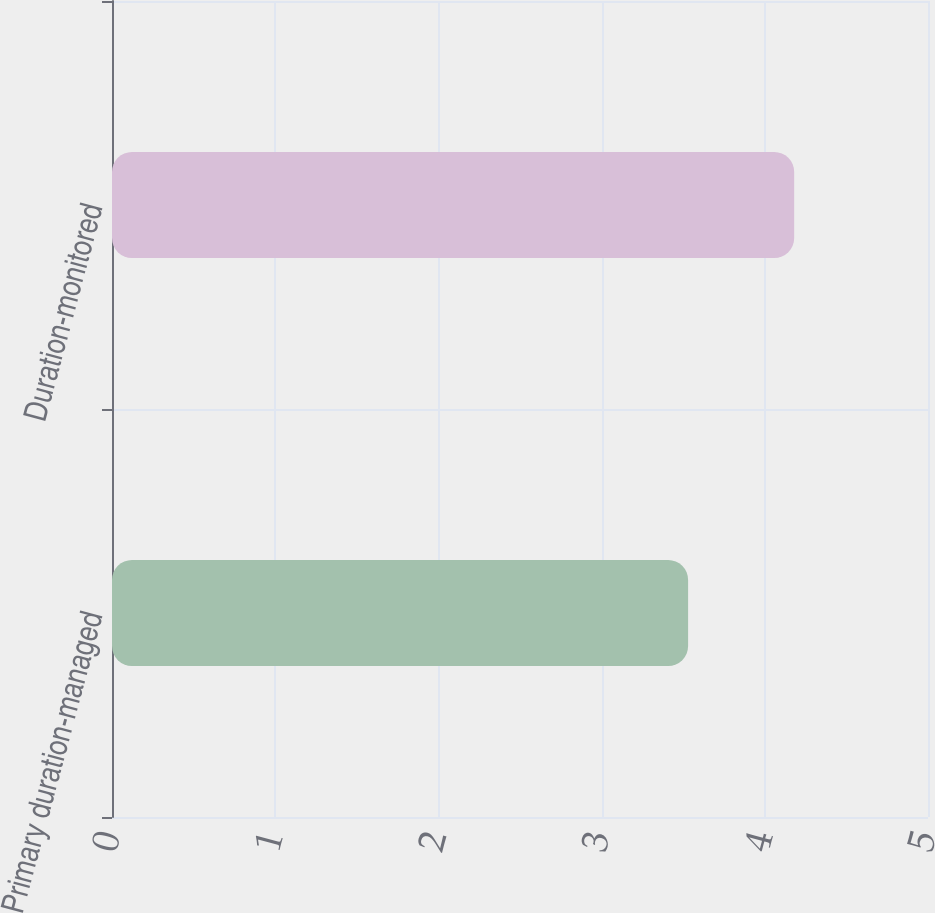Convert chart to OTSL. <chart><loc_0><loc_0><loc_500><loc_500><bar_chart><fcel>Primary duration-managed<fcel>Duration-monitored<nl><fcel>3.53<fcel>4.18<nl></chart> 